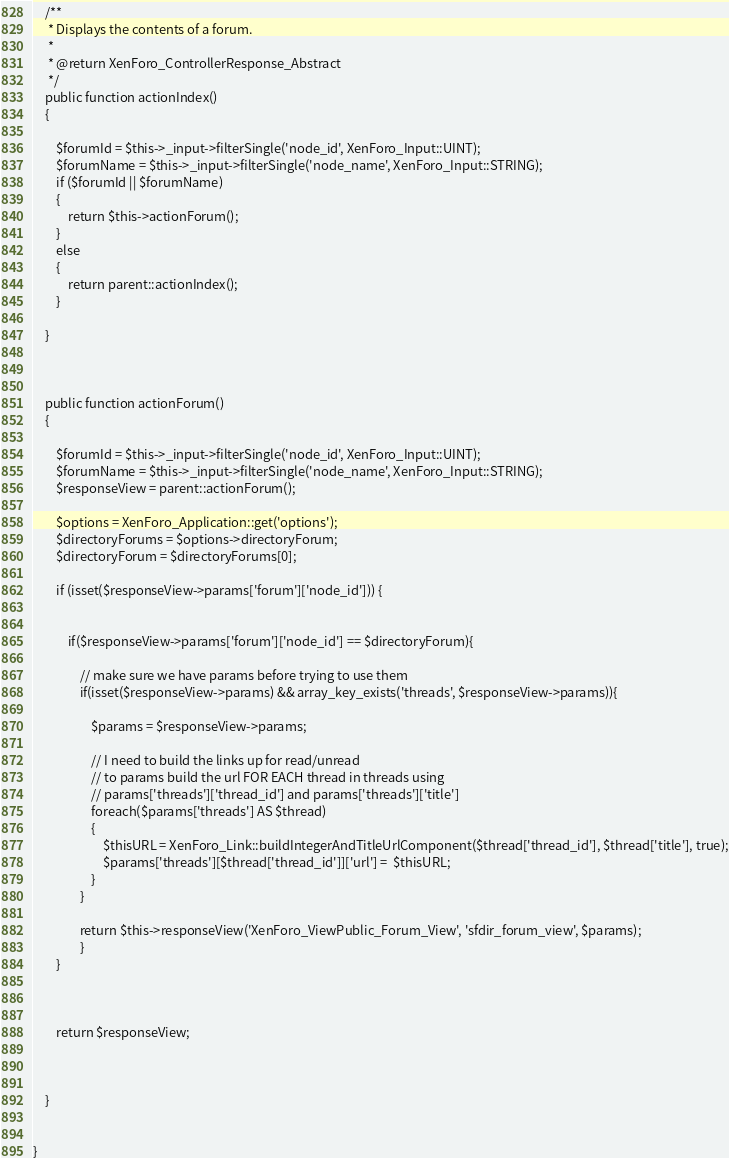<code> <loc_0><loc_0><loc_500><loc_500><_PHP_>	/**
	 * Displays the contents of a forum.
	 *
	 * @return XenForo_ControllerResponse_Abstract
	 */
	public function actionIndex()
	{
		
		$forumId = $this->_input->filterSingle('node_id', XenForo_Input::UINT);
		$forumName = $this->_input->filterSingle('node_name', XenForo_Input::STRING);
		if ($forumId || $forumName)
		{
			return $this->actionForum();
		}
		else
		{
			return parent::actionIndex();
		}

	}

	
	
	public function actionForum()
	{
		
		$forumId = $this->_input->filterSingle('node_id', XenForo_Input::UINT);
		$forumName = $this->_input->filterSingle('node_name', XenForo_Input::STRING);
		$responseView = parent::actionForum();

		$options = XenForo_Application::get('options');
		$directoryForums = $options->directoryForum;
		$directoryForum = $directoryForums[0];

		if (isset($responseView->params['forum']['node_id'])) {
			
			
			if($responseView->params['forum']['node_id'] == $directoryForum){
			
				// make sure we have params before trying to use them
				if(isset($responseView->params) && array_key_exists('threads', $responseView->params)){
					
					$params = $responseView->params;
							
					// I need to build the links up for read/unread 
					// to params build the url FOR EACH thread in threads using
					// params['threads']['thread_id'] and params['threads']['title']		
					foreach($params['threads'] AS $thread)
					{
						$thisURL = XenForo_Link::buildIntegerAndTitleUrlComponent($thread['thread_id'], $thread['title'], true);
						$params['threads'][$thread['thread_id']]['url'] =  $thisURL;
					}
				}			
				
				return $this->responseView('XenForo_ViewPublic_Forum_View', 'sfdir_forum_view', $params);
				}
		}
		
		

		return $responseView;		
		
		
				
	}	
	
	
}</code> 